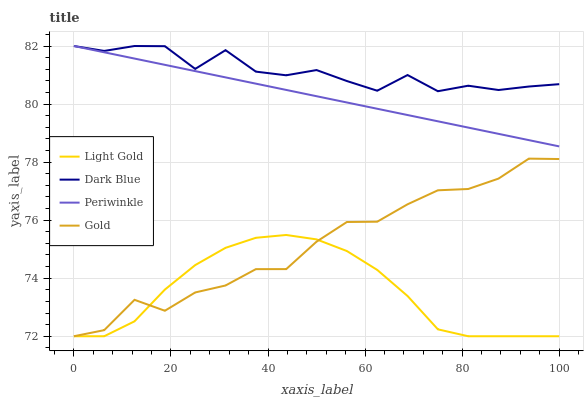Does Periwinkle have the minimum area under the curve?
Answer yes or no. No. Does Periwinkle have the maximum area under the curve?
Answer yes or no. No. Is Light Gold the smoothest?
Answer yes or no. No. Is Light Gold the roughest?
Answer yes or no. No. Does Periwinkle have the lowest value?
Answer yes or no. No. Does Light Gold have the highest value?
Answer yes or no. No. Is Gold less than Dark Blue?
Answer yes or no. Yes. Is Dark Blue greater than Gold?
Answer yes or no. Yes. Does Gold intersect Dark Blue?
Answer yes or no. No. 